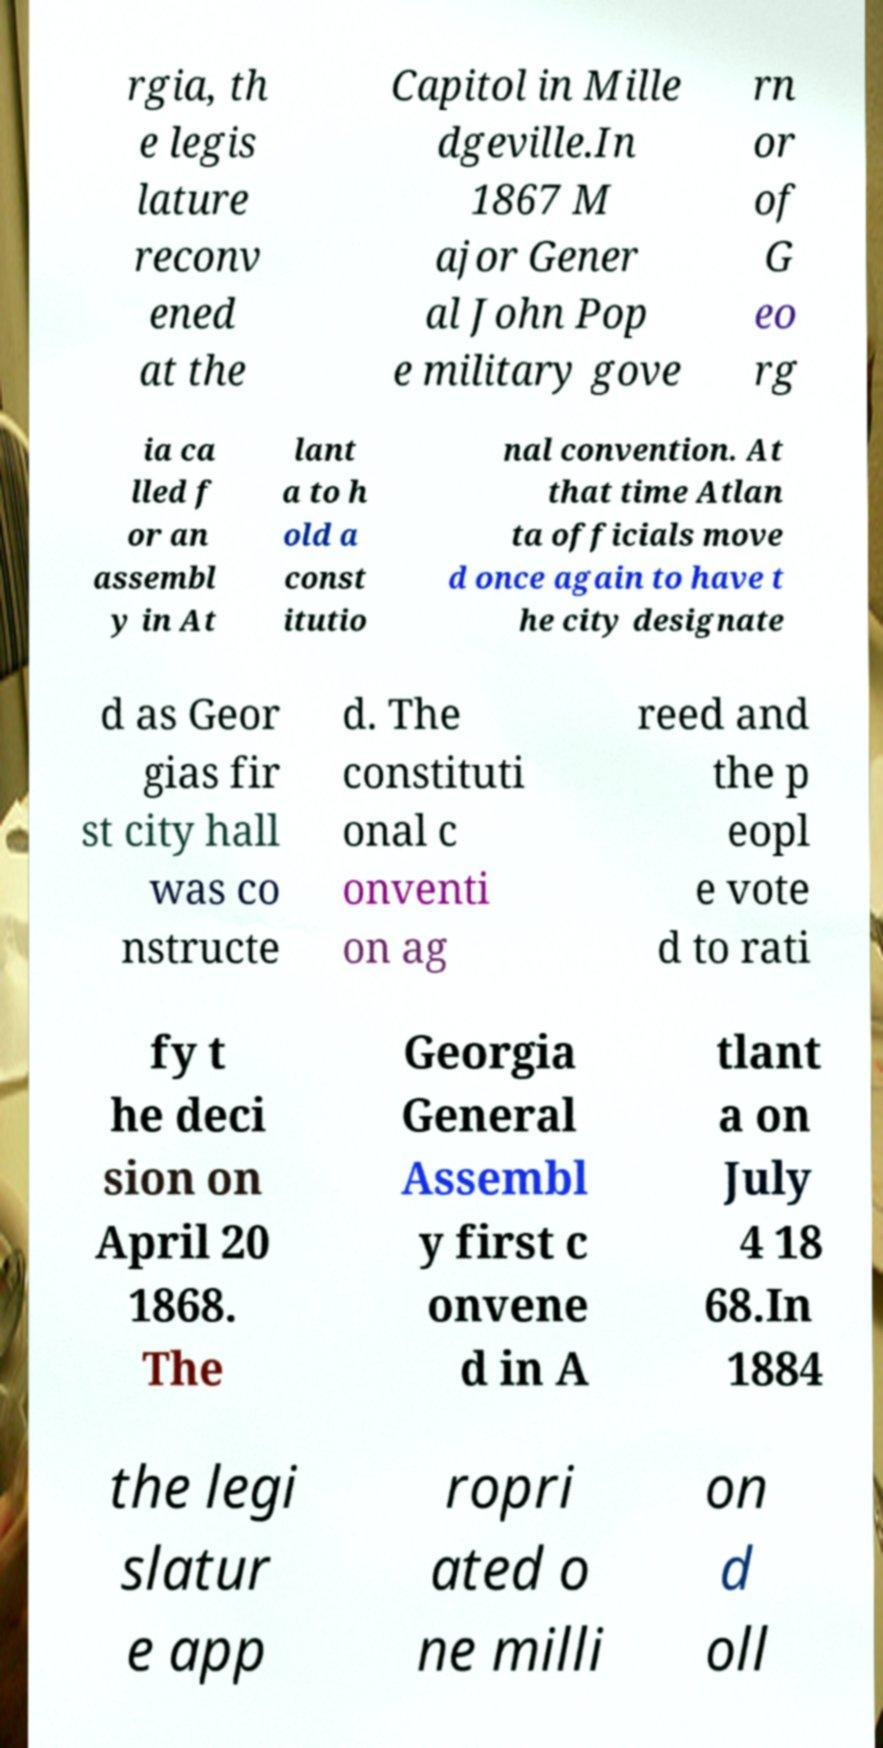Can you accurately transcribe the text from the provided image for me? rgia, th e legis lature reconv ened at the Capitol in Mille dgeville.In 1867 M ajor Gener al John Pop e military gove rn or of G eo rg ia ca lled f or an assembl y in At lant a to h old a const itutio nal convention. At that time Atlan ta officials move d once again to have t he city designate d as Geor gias fir st city hall was co nstructe d. The constituti onal c onventi on ag reed and the p eopl e vote d to rati fy t he deci sion on April 20 1868. The Georgia General Assembl y first c onvene d in A tlant a on July 4 18 68.In 1884 the legi slatur e app ropri ated o ne milli on d oll 